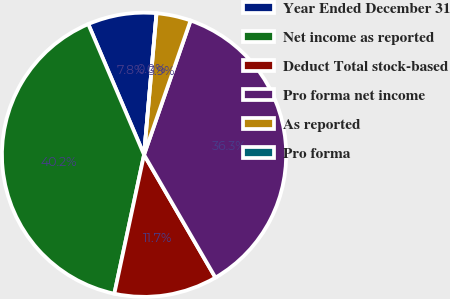Convert chart to OTSL. <chart><loc_0><loc_0><loc_500><loc_500><pie_chart><fcel>Year Ended December 31<fcel>Net income as reported<fcel>Deduct Total stock-based<fcel>Pro forma net income<fcel>As reported<fcel>Pro forma<nl><fcel>7.82%<fcel>40.22%<fcel>11.73%<fcel>36.31%<fcel>3.91%<fcel>0.0%<nl></chart> 